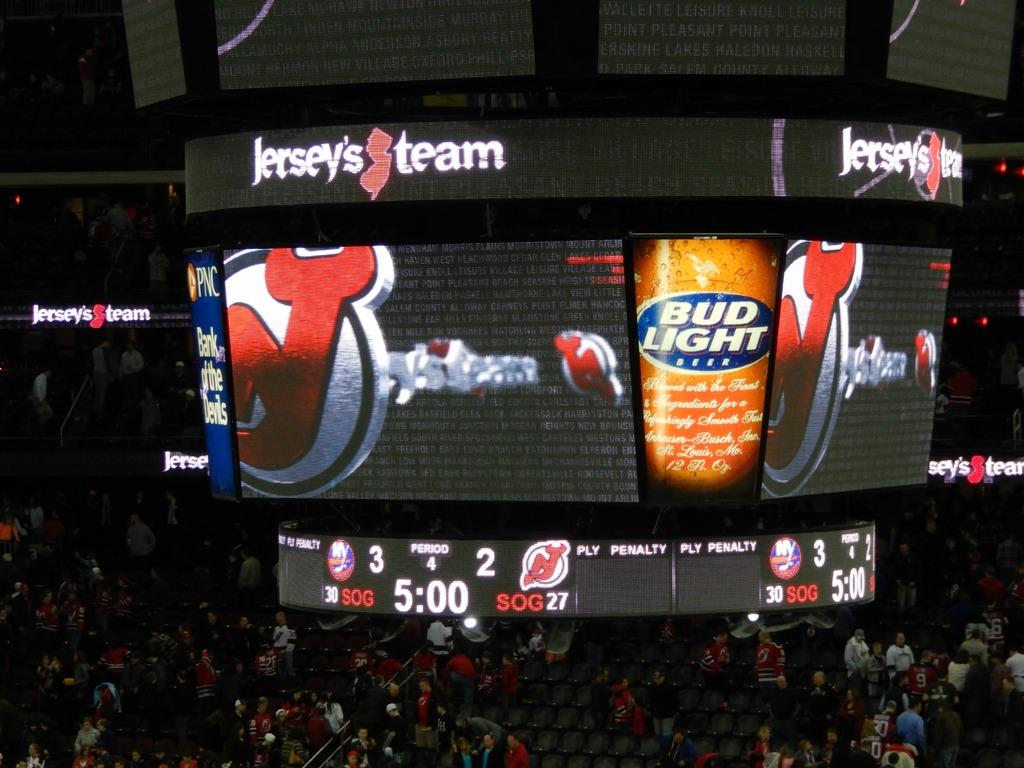What is the name of the beer that on the score board?
Give a very brief answer. Bud light. What team is mentioned on the score board?
Provide a short and direct response. Jersey's team. 